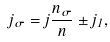<formula> <loc_0><loc_0><loc_500><loc_500>j _ { \sigma } = j \frac { n _ { \sigma } } { n } \pm j _ { 1 } ,</formula> 